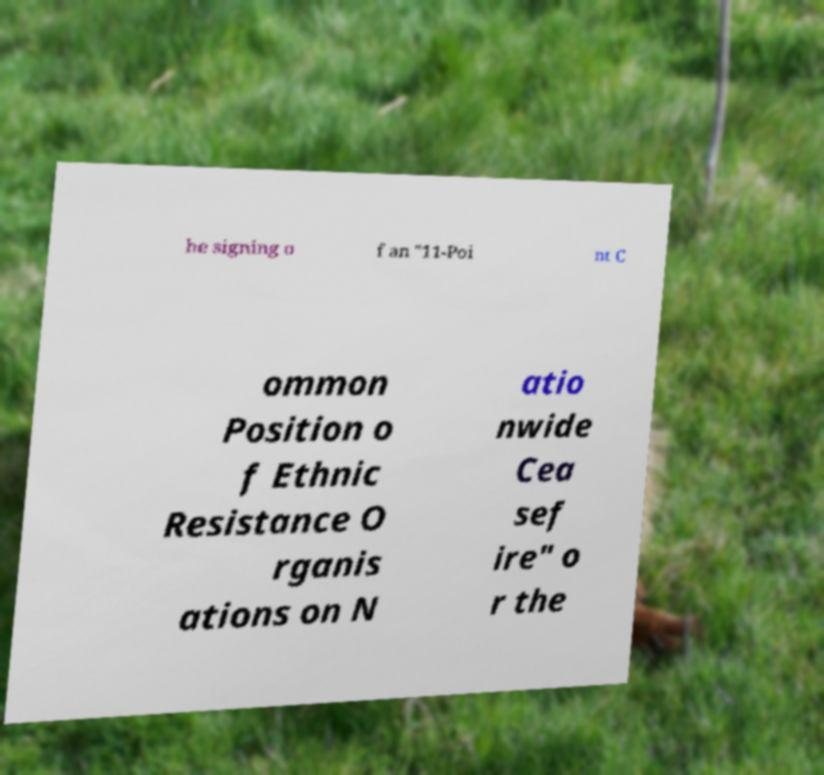Can you accurately transcribe the text from the provided image for me? he signing o f an "11-Poi nt C ommon Position o f Ethnic Resistance O rganis ations on N atio nwide Cea sef ire" o r the 